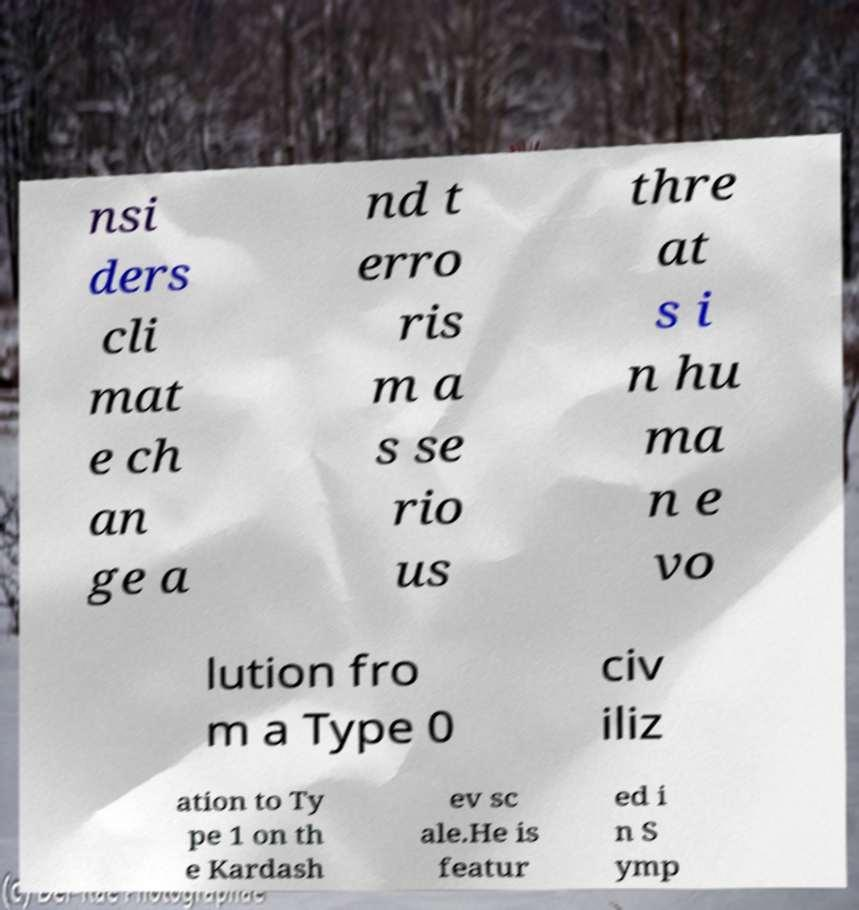Can you read and provide the text displayed in the image?This photo seems to have some interesting text. Can you extract and type it out for me? nsi ders cli mat e ch an ge a nd t erro ris m a s se rio us thre at s i n hu ma n e vo lution fro m a Type 0 civ iliz ation to Ty pe 1 on th e Kardash ev sc ale.He is featur ed i n S ymp 